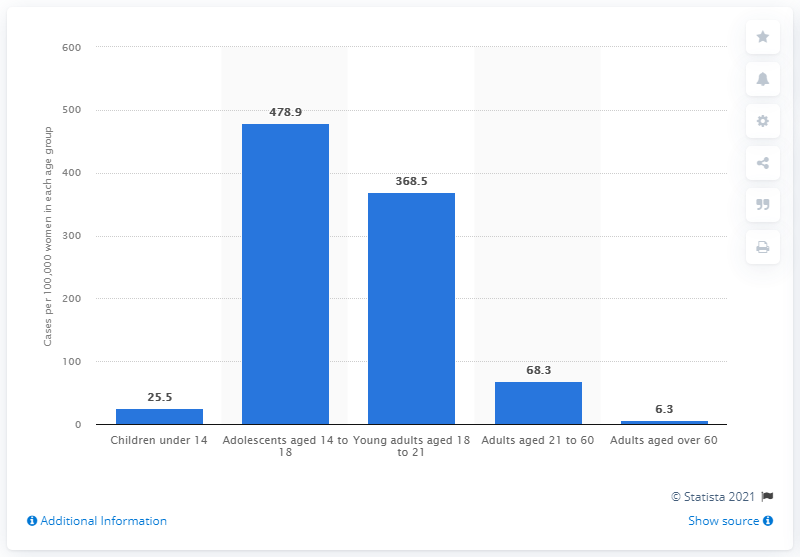Identify some key points in this picture. In 2020, there were 478.9 females who were victims of crimes against sexual self-determination in Germany. 